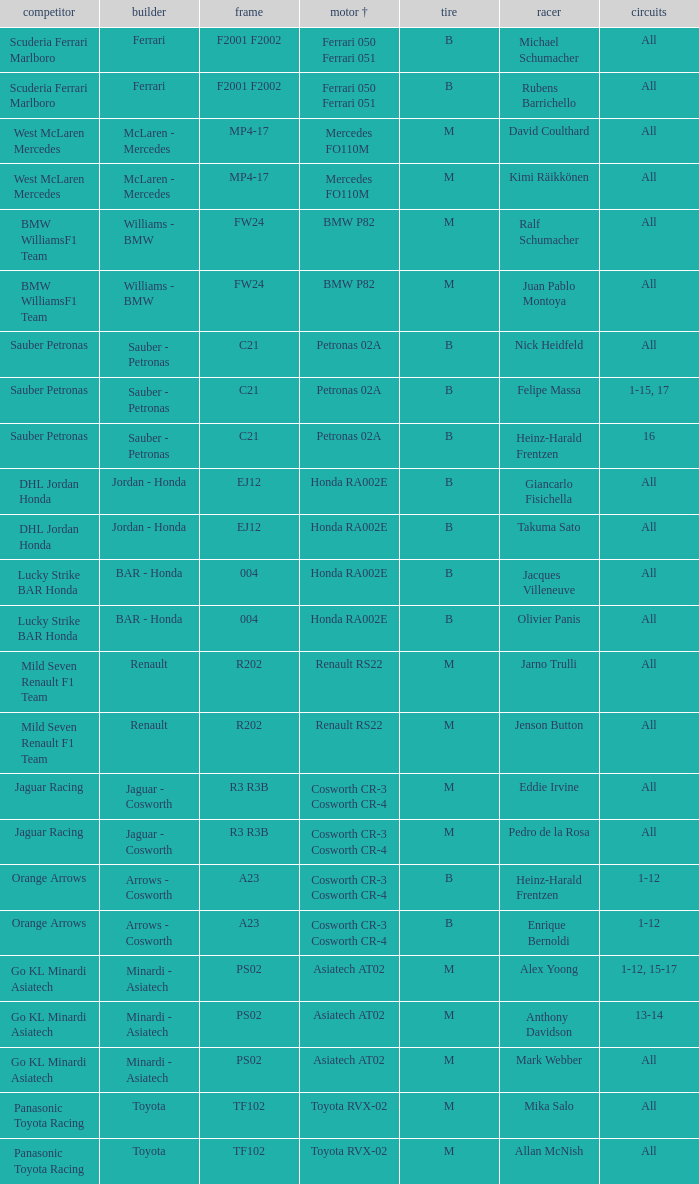What is the engine when the rounds ar all, the tyre is m and the driver is david coulthard? Mercedes FO110M. 